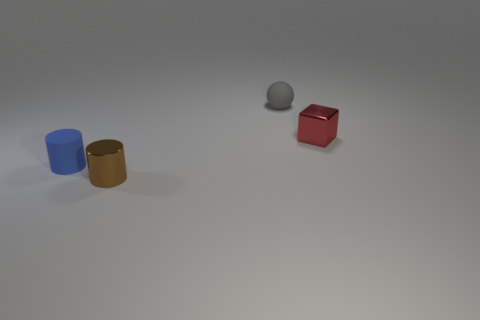What shape is the red shiny thing that is the same size as the brown metallic object?
Keep it short and to the point. Cube. Are there any other tiny blue matte objects that have the same shape as the blue object?
Offer a very short reply. No. Is the material of the small blue thing the same as the small cylinder that is in front of the small blue cylinder?
Provide a short and direct response. No. What is the material of the tiny cylinder that is in front of the rubber thing on the left side of the gray rubber sphere?
Offer a terse response. Metal. Is the number of tiny metal cylinders that are on the right side of the tiny brown shiny object greater than the number of tiny green shiny cubes?
Your answer should be compact. No. Are there any green matte spheres?
Provide a short and direct response. No. What is the color of the small shiny object left of the red object?
Offer a terse response. Brown. There is a blue object that is the same size as the brown thing; what material is it?
Keep it short and to the point. Rubber. What number of other objects are the same material as the small brown cylinder?
Your answer should be compact. 1. What is the color of the object that is both in front of the small ball and behind the blue matte thing?
Ensure brevity in your answer.  Red. 